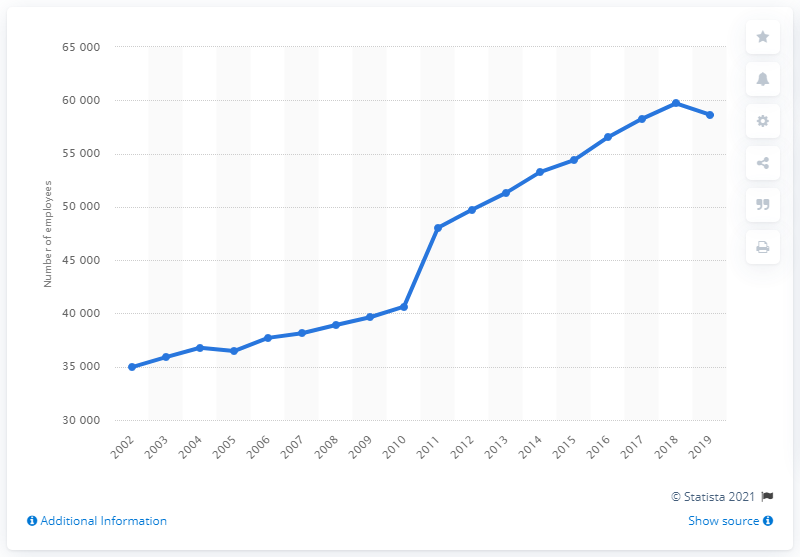Highlight a few significant elements in this photo. In 2019, there were approximately 58,640 pharmacists employed in the United Kingdom. 